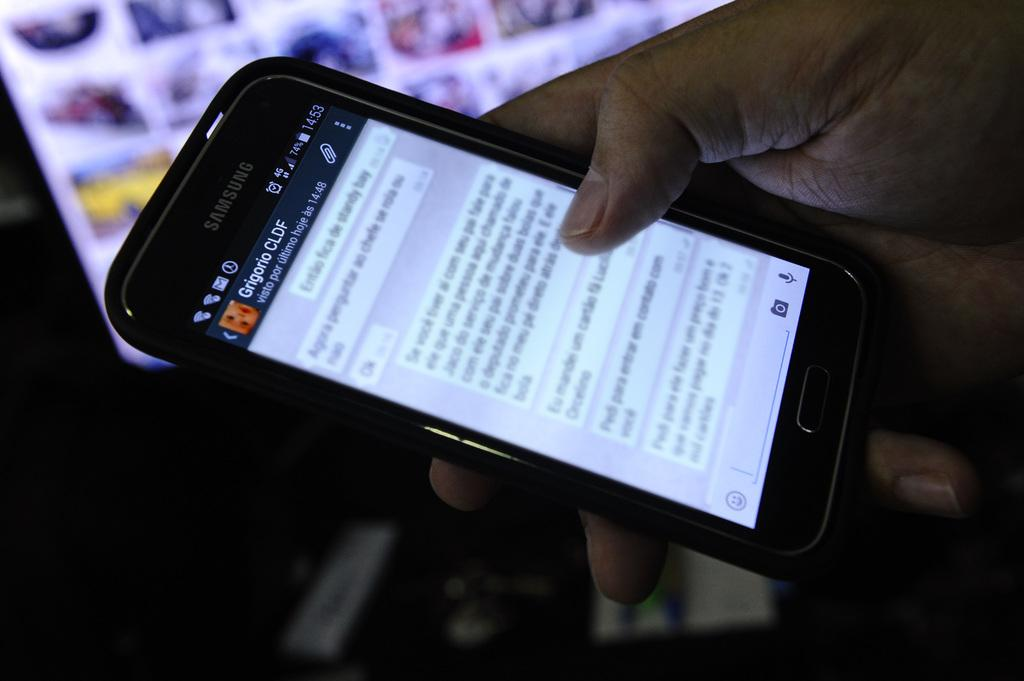<image>
Offer a succinct explanation of the picture presented. A hand holding a black Samsung smartphone with a bright screen 